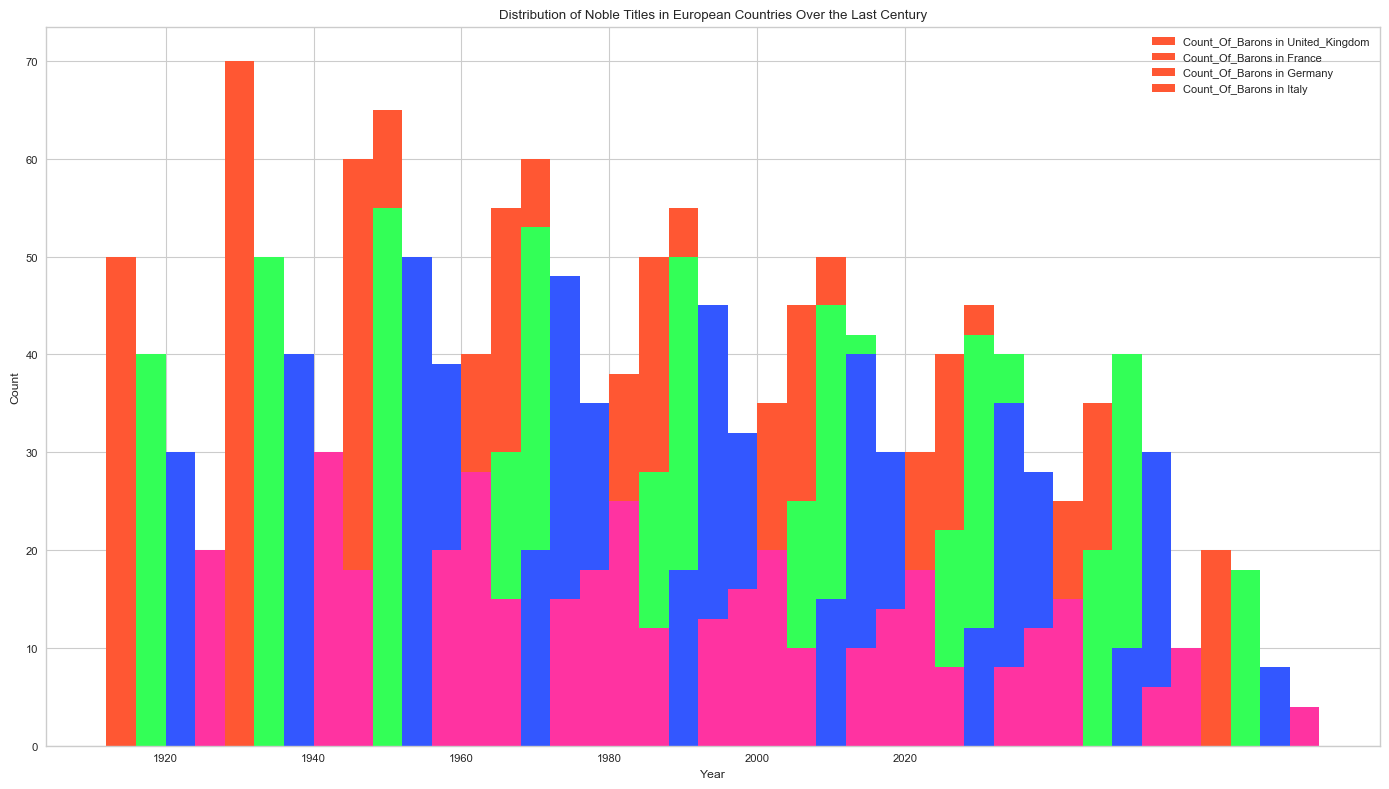What is the overall trend in the number of Barons in the United Kingdom from 1920 to 2020? To determine the trend, observe the heights of the bars corresponding to the Count of Barons for the United Kingdom from 1920 to 2020. The heights decrease over time. From 1920 (50) to 2020 (25), there is a steady decline.
Answer: Steady decline Which country had the highest number of Earls in 1920? Compare the heights of the bars representing the Count of Earls in 1920 for all countries. The tallest bar is for Germany.
Answer: Germany In which year did Italy have the least number of Dukes? Identify the bars representing the Count of Dukes for Italy over all the years and find the shortest bar, which is in 2020 with 8 Dukes.
Answer: 2020 Is there a year when the number of Princes is equal across any of the countries? Examine the height of the bars for the Count of Princes across all years for each country. In 2000, both the United Kingdom and France have 8 Princes.
Answer: Yes, 2000 How does the count of Earls in the United Kingdom in 1940 compare to the count in Germany in the same year? Observe the heights of the bars representing the Count of Earls for both the United Kingdom and Germany in 1940. The count in the United Kingdom is 38 and in Germany is 53, so Germany had more Earls.
Answer: Germany had more What is the sum of the counts of Dukes in France and Germany in 1960? Add the heights of the bars representing the Count of Dukes in France and Germany for 1960. France has 35 Dukes and Germany has 45 Dukes, summing to 80.
Answer: 80 Which country had the most significant decrease in the number of Princes from 1920 to 2020? Compare the decrease in the heights of bars representing the Count of Princes for each country from 1920 to 2020. The largest drop is in Italy, from 15 to 4 Princes, a decrease of 11.
Answer: Italy Has there been a period where the number of Earls remained stable for any country? Look for flat lines in the bar heights representing Earls, indicating no change. For the United Kingdom, from 1980 to 2000, the count remained at 35.
Answer: United Kingdom (1980-2000) What is the difference in the count of Barons between France and Italy in 2020? Observe the height of the bars for the Count of Barons in France and Italy in 2020. France has 45 Barons, and Italy has 20 Barons, resulting in a difference of 25.
Answer: 25 